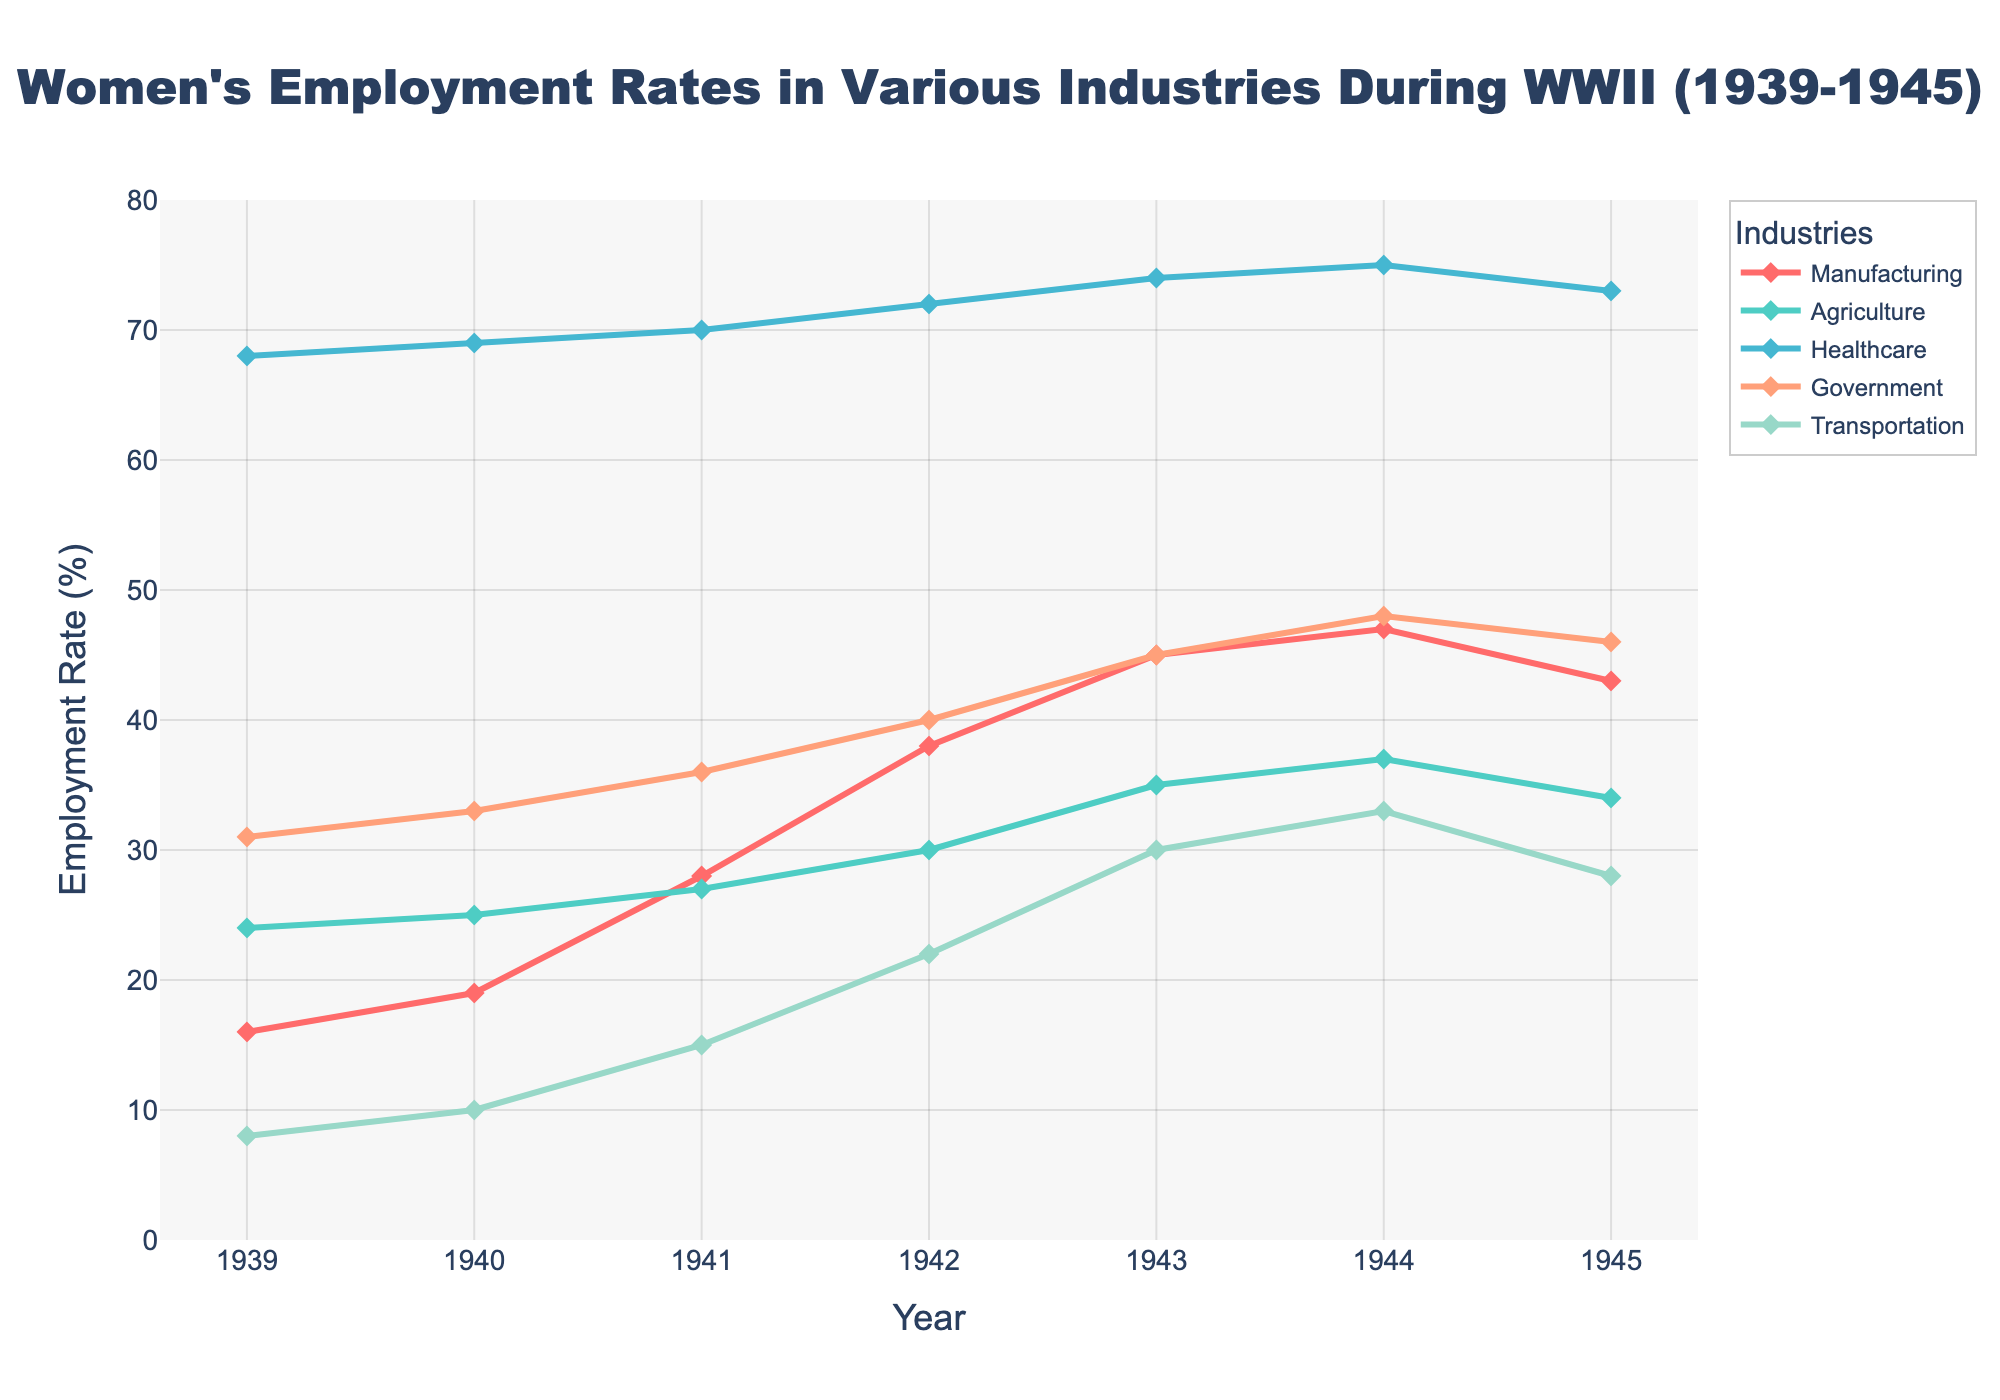What trend can be observed in women's employment rates in the Manufacturing sector from 1939 to 1945? The line chart shows the employment rate in the Manufacturing sector increasing from 16% in 1939 to a peak of 47% in 1944. In 1945, the rate decreases slightly to 43%. The general trend is an increase with a slight drop at the end.
Answer: Increasing with a slight drop in 1945 In which year did the Transportation sector see the highest employment rate for women? The highest employment rate in the Transportation sector is seen in 1944, reaching 33%.
Answer: 1944 Compare the employment rates of women in Agriculture and Government sectors in 1943. Which sector had a higher rate? In 1943, the employment rate in Agriculture is 35%, while in the Government sector it is 45%. Thus, the Government sector had a higher rate.
Answer: Government What is the overall change in women's employment rate in the Healthcare sector from 1939 to 1945? The rate in the Healthcare sector increases from 68% in 1939 to 73% in 1945. The change is calculated as 73% - 68% = 5%.
Answer: 5% What combination of years had the same employment rate for women in both the Manufacturing and Government sectors? The year 1945 had the employment rate of 43% in the Manufacturing sector and 46% in the Government sector. This exact combination did not repeat across the years. Therefore, there are no years with the same employment rate in both sectors.
Answer: None Which industry shows the most consistent increase in employment rates from 1939 to 1945? The Government sector shows the most consistent increase, rising from 31% in 1939 to 46% in 1945 without any dips.
Answer: Government Calculate the average employment rate in the Agriculture sector over the years. The rates are 24, 25, 27, 30, 35, 37, and 34. The sum is 212 and there are 7 data points. Hence, the average is 212 / 7 ≈ 30.3%.
Answer: 30.3% Which industry experienced the highest absolute increase in employment rates from 1939 to its peak year, and what is the value of this increase? The Manufacturing sector saw an increase from 16% in 1939 to a peak of 47% in 1944, an increase of 31%.
Answer: Manufacturing, 31% 